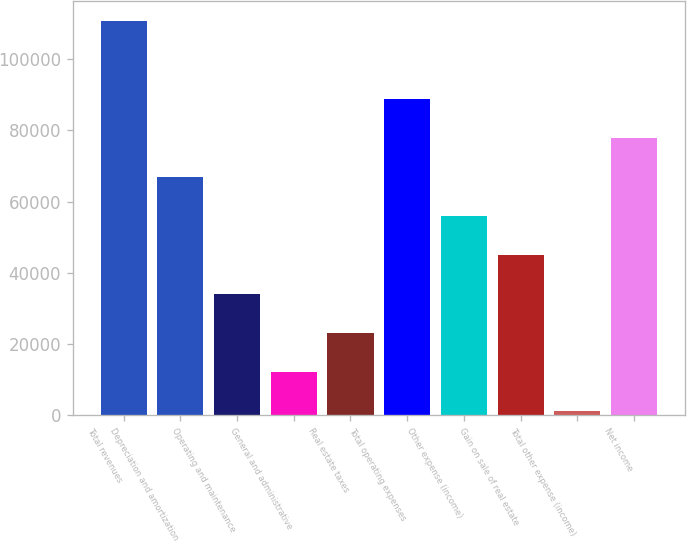Convert chart to OTSL. <chart><loc_0><loc_0><loc_500><loc_500><bar_chart><fcel>Total revenues<fcel>Depreciation and amortization<fcel>Operating and maintenance<fcel>General and administrative<fcel>Real estate taxes<fcel>Total operating expenses<fcel>Other expense (income)<fcel>Gain on sale of real estate<fcel>Total other expense (income)<fcel>Net income<nl><fcel>110939<fcel>66972.6<fcel>33997.8<fcel>12014.6<fcel>23006.2<fcel>88955.8<fcel>55981<fcel>44989.4<fcel>1023<fcel>77964.2<nl></chart> 